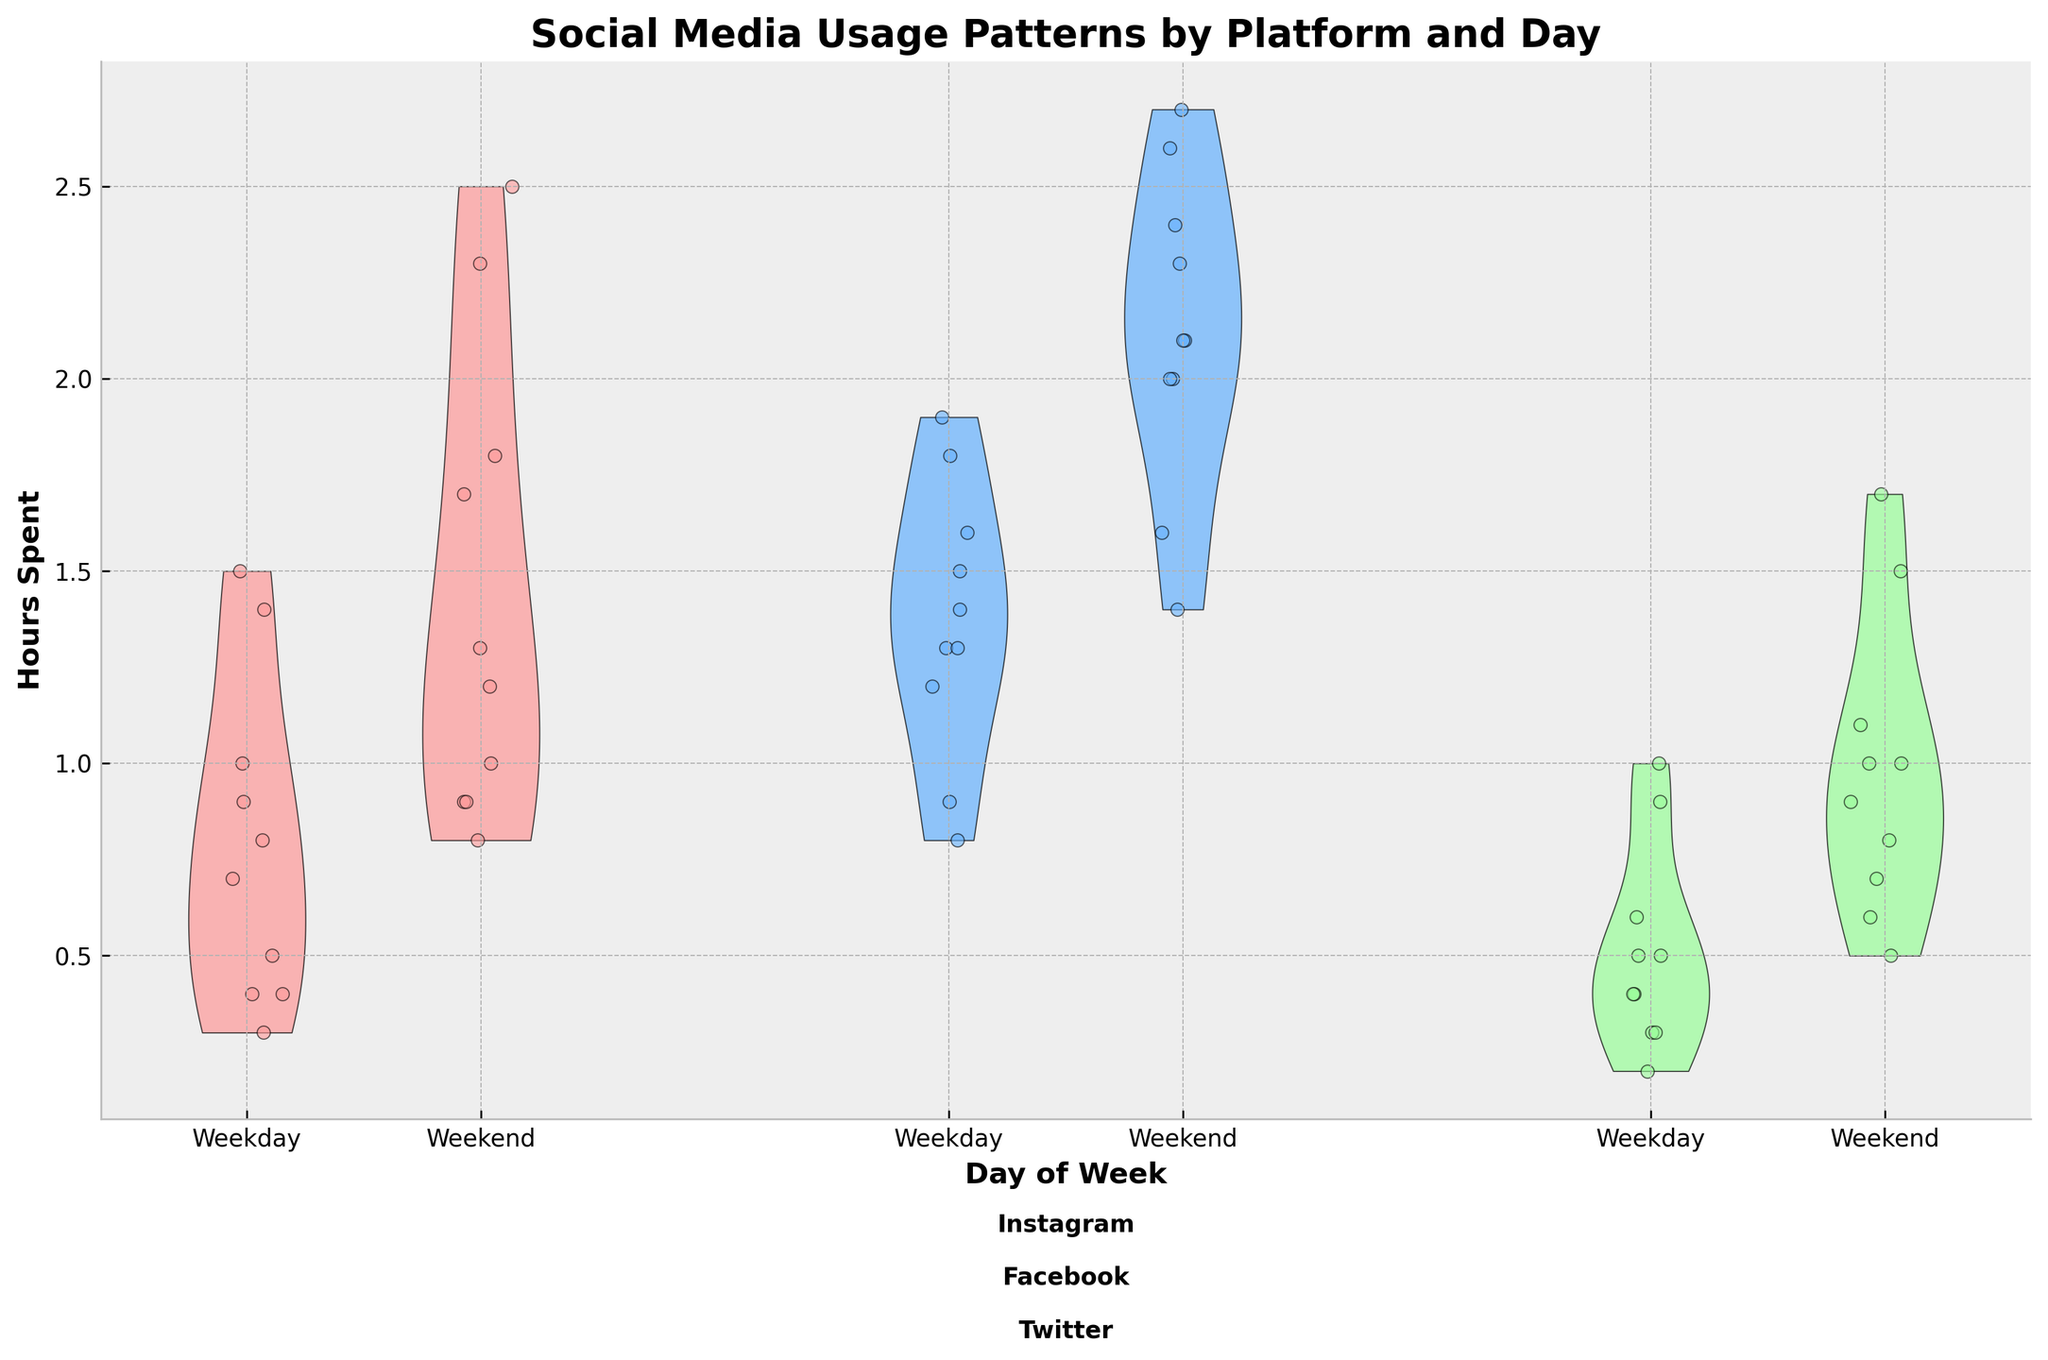What is the title of the figure? The title of the figure is usually found at the top of the chart. In this case, it should clearly describe what the chart is about.
Answer: Social Media Usage Patterns by Platform and Day What are the x-axis labels? The x-axis labels tell us the categories of the data plotted on the horizontal axis. Here, it separates the data into Weekday and Weekend categories for each social media platform.
Answer: Weekday, Weekend How many platforms are being compared in the chart? By looking at the violin plots and the scatter points, we can identify the number of different social media platforms shown.
Answer: 3 Which age group shows the highest variance in Instagram usage during weekends? The variance can be inferred by looking at the spread of the violin plots and the scatter points on the weekends for Instagram.
Answer: 18-24 Which social media platform had higher average usage on weekdays for the age group 35-44, Facebook or Instagram? By comparing the central tendency (mean or median) of the violin plots and jittered points for Instagram and Facebook on weekdays for the age group 35-44.
Answer: Facebook On which day of the week do people aged 25-34 spend more time on Twitter? We should compare the median or average of the violin plots and scatter points for Twitter on weekdays and weekends for age group 25-34.
Answer: Weekend What does the violin plot represent in this figure? The violin plot shows the distribution of the dataset for each platform and day. The width of the plot at different y-values indicates the frequency/probability density of the data points at those values.
Answer: Distribution of dataset Which social media platform has the lowest median usage hours on weekdays for the age group 45-54? By comparing the central line (median) or the midpoint of the violin plots for different platforms on weekdays for the age group 45-54.
Answer: Twitter How does Facebook usage change from weekdays to weekends for people aged 55-64? By observing the differences in spread, median, and central tendencies of the violin plots for Facebook from weekdays to weekends for age group 55-64.
Answer: It increases Which day shows a smaller overall variance in social media usage for the age group 18-24? Variance can be assessed by looking at the spread of the scatter points and the shape of the violin plots for both weekdays and weekends for age group 18-24.
Answer: Weekday 